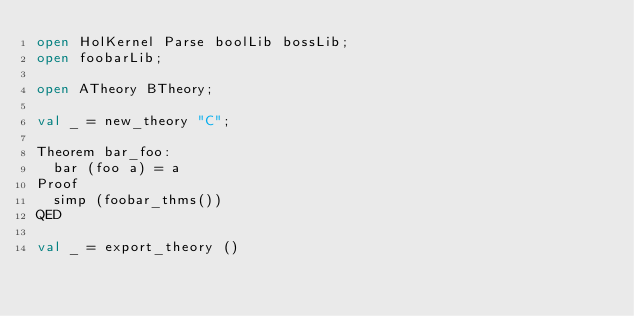<code> <loc_0><loc_0><loc_500><loc_500><_SML_>open HolKernel Parse boolLib bossLib;
open foobarLib;

open ATheory BTheory;

val _ = new_theory "C";

Theorem bar_foo:
  bar (foo a) = a
Proof
  simp (foobar_thms())
QED

val _ = export_theory ()
</code> 